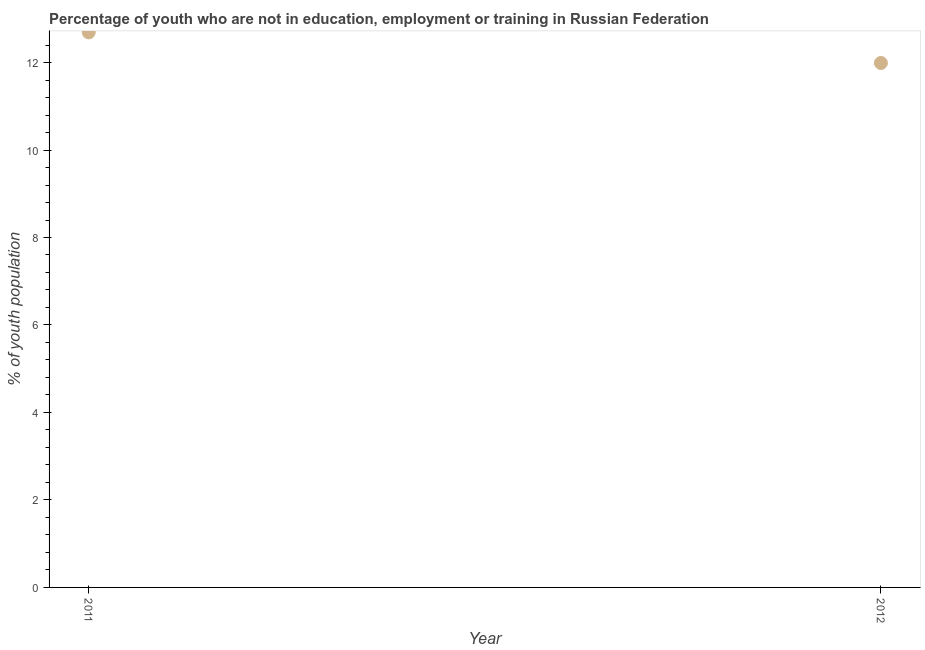What is the unemployed youth population in 2011?
Your answer should be compact. 12.69. Across all years, what is the maximum unemployed youth population?
Provide a succinct answer. 12.69. Across all years, what is the minimum unemployed youth population?
Give a very brief answer. 11.99. In which year was the unemployed youth population maximum?
Keep it short and to the point. 2011. What is the sum of the unemployed youth population?
Your answer should be very brief. 24.68. What is the difference between the unemployed youth population in 2011 and 2012?
Provide a short and direct response. 0.7. What is the average unemployed youth population per year?
Give a very brief answer. 12.34. What is the median unemployed youth population?
Give a very brief answer. 12.34. In how many years, is the unemployed youth population greater than 1.2000000000000002 %?
Offer a terse response. 2. What is the ratio of the unemployed youth population in 2011 to that in 2012?
Your answer should be compact. 1.06. Does the unemployed youth population monotonically increase over the years?
Keep it short and to the point. No. Are the values on the major ticks of Y-axis written in scientific E-notation?
Your answer should be very brief. No. Does the graph contain any zero values?
Your answer should be compact. No. What is the title of the graph?
Your answer should be compact. Percentage of youth who are not in education, employment or training in Russian Federation. What is the label or title of the X-axis?
Make the answer very short. Year. What is the label or title of the Y-axis?
Your response must be concise. % of youth population. What is the % of youth population in 2011?
Give a very brief answer. 12.69. What is the % of youth population in 2012?
Give a very brief answer. 11.99. What is the ratio of the % of youth population in 2011 to that in 2012?
Offer a very short reply. 1.06. 